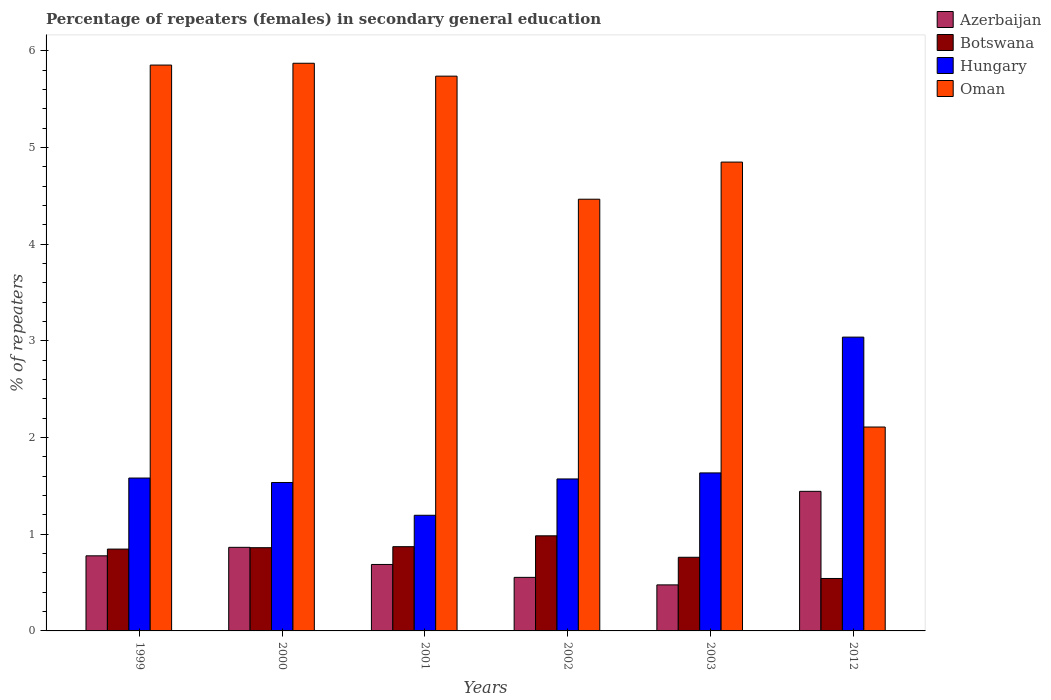How many different coloured bars are there?
Provide a succinct answer. 4. How many groups of bars are there?
Give a very brief answer. 6. Are the number of bars on each tick of the X-axis equal?
Provide a short and direct response. Yes. In how many cases, is the number of bars for a given year not equal to the number of legend labels?
Keep it short and to the point. 0. What is the percentage of female repeaters in Hungary in 1999?
Offer a very short reply. 1.58. Across all years, what is the maximum percentage of female repeaters in Azerbaijan?
Give a very brief answer. 1.44. Across all years, what is the minimum percentage of female repeaters in Hungary?
Offer a very short reply. 1.2. In which year was the percentage of female repeaters in Botswana minimum?
Offer a very short reply. 2012. What is the total percentage of female repeaters in Azerbaijan in the graph?
Make the answer very short. 4.8. What is the difference between the percentage of female repeaters in Oman in 2002 and that in 2003?
Provide a short and direct response. -0.38. What is the difference between the percentage of female repeaters in Hungary in 2000 and the percentage of female repeaters in Botswana in 2012?
Your answer should be compact. 0.99. What is the average percentage of female repeaters in Azerbaijan per year?
Your answer should be compact. 0.8. In the year 2012, what is the difference between the percentage of female repeaters in Botswana and percentage of female repeaters in Hungary?
Your response must be concise. -2.5. What is the ratio of the percentage of female repeaters in Azerbaijan in 1999 to that in 2012?
Your answer should be very brief. 0.54. Is the percentage of female repeaters in Oman in 2000 less than that in 2001?
Give a very brief answer. No. Is the difference between the percentage of female repeaters in Botswana in 1999 and 2012 greater than the difference between the percentage of female repeaters in Hungary in 1999 and 2012?
Your answer should be very brief. Yes. What is the difference between the highest and the second highest percentage of female repeaters in Oman?
Make the answer very short. 0.02. What is the difference between the highest and the lowest percentage of female repeaters in Botswana?
Your response must be concise. 0.44. Is it the case that in every year, the sum of the percentage of female repeaters in Azerbaijan and percentage of female repeaters in Oman is greater than the sum of percentage of female repeaters in Hungary and percentage of female repeaters in Botswana?
Make the answer very short. No. What does the 1st bar from the left in 2003 represents?
Ensure brevity in your answer.  Azerbaijan. What does the 4th bar from the right in 2001 represents?
Your answer should be compact. Azerbaijan. Is it the case that in every year, the sum of the percentage of female repeaters in Oman and percentage of female repeaters in Azerbaijan is greater than the percentage of female repeaters in Hungary?
Ensure brevity in your answer.  Yes. Are all the bars in the graph horizontal?
Give a very brief answer. No. What is the difference between two consecutive major ticks on the Y-axis?
Give a very brief answer. 1. Does the graph contain any zero values?
Offer a terse response. No. What is the title of the graph?
Your response must be concise. Percentage of repeaters (females) in secondary general education. What is the label or title of the Y-axis?
Offer a very short reply. % of repeaters. What is the % of repeaters of Azerbaijan in 1999?
Provide a short and direct response. 0.78. What is the % of repeaters in Botswana in 1999?
Offer a terse response. 0.85. What is the % of repeaters of Hungary in 1999?
Keep it short and to the point. 1.58. What is the % of repeaters in Oman in 1999?
Make the answer very short. 5.85. What is the % of repeaters of Azerbaijan in 2000?
Ensure brevity in your answer.  0.86. What is the % of repeaters of Botswana in 2000?
Make the answer very short. 0.86. What is the % of repeaters in Hungary in 2000?
Make the answer very short. 1.53. What is the % of repeaters in Oman in 2000?
Your answer should be very brief. 5.87. What is the % of repeaters of Azerbaijan in 2001?
Your answer should be very brief. 0.69. What is the % of repeaters in Botswana in 2001?
Provide a succinct answer. 0.87. What is the % of repeaters in Hungary in 2001?
Provide a succinct answer. 1.2. What is the % of repeaters in Oman in 2001?
Your answer should be very brief. 5.74. What is the % of repeaters of Azerbaijan in 2002?
Offer a very short reply. 0.55. What is the % of repeaters in Botswana in 2002?
Keep it short and to the point. 0.98. What is the % of repeaters in Hungary in 2002?
Your answer should be compact. 1.57. What is the % of repeaters of Oman in 2002?
Provide a short and direct response. 4.46. What is the % of repeaters in Azerbaijan in 2003?
Provide a short and direct response. 0.48. What is the % of repeaters of Botswana in 2003?
Provide a short and direct response. 0.76. What is the % of repeaters in Hungary in 2003?
Your answer should be compact. 1.63. What is the % of repeaters of Oman in 2003?
Ensure brevity in your answer.  4.85. What is the % of repeaters of Azerbaijan in 2012?
Offer a terse response. 1.44. What is the % of repeaters in Botswana in 2012?
Make the answer very short. 0.54. What is the % of repeaters of Hungary in 2012?
Offer a very short reply. 3.04. What is the % of repeaters of Oman in 2012?
Provide a succinct answer. 2.11. Across all years, what is the maximum % of repeaters in Azerbaijan?
Your response must be concise. 1.44. Across all years, what is the maximum % of repeaters of Botswana?
Provide a succinct answer. 0.98. Across all years, what is the maximum % of repeaters of Hungary?
Give a very brief answer. 3.04. Across all years, what is the maximum % of repeaters of Oman?
Provide a succinct answer. 5.87. Across all years, what is the minimum % of repeaters in Azerbaijan?
Ensure brevity in your answer.  0.48. Across all years, what is the minimum % of repeaters in Botswana?
Your answer should be very brief. 0.54. Across all years, what is the minimum % of repeaters of Hungary?
Your answer should be compact. 1.2. Across all years, what is the minimum % of repeaters of Oman?
Your response must be concise. 2.11. What is the total % of repeaters of Azerbaijan in the graph?
Provide a succinct answer. 4.8. What is the total % of repeaters of Botswana in the graph?
Make the answer very short. 4.87. What is the total % of repeaters in Hungary in the graph?
Provide a succinct answer. 10.56. What is the total % of repeaters in Oman in the graph?
Offer a very short reply. 28.88. What is the difference between the % of repeaters in Azerbaijan in 1999 and that in 2000?
Provide a succinct answer. -0.09. What is the difference between the % of repeaters of Botswana in 1999 and that in 2000?
Your answer should be compact. -0.01. What is the difference between the % of repeaters of Hungary in 1999 and that in 2000?
Offer a very short reply. 0.05. What is the difference between the % of repeaters of Oman in 1999 and that in 2000?
Provide a short and direct response. -0.02. What is the difference between the % of repeaters in Azerbaijan in 1999 and that in 2001?
Your answer should be very brief. 0.09. What is the difference between the % of repeaters in Botswana in 1999 and that in 2001?
Offer a terse response. -0.02. What is the difference between the % of repeaters in Hungary in 1999 and that in 2001?
Ensure brevity in your answer.  0.39. What is the difference between the % of repeaters of Oman in 1999 and that in 2001?
Provide a succinct answer. 0.11. What is the difference between the % of repeaters in Azerbaijan in 1999 and that in 2002?
Make the answer very short. 0.22. What is the difference between the % of repeaters in Botswana in 1999 and that in 2002?
Ensure brevity in your answer.  -0.14. What is the difference between the % of repeaters of Hungary in 1999 and that in 2002?
Provide a succinct answer. 0.01. What is the difference between the % of repeaters in Oman in 1999 and that in 2002?
Keep it short and to the point. 1.39. What is the difference between the % of repeaters of Azerbaijan in 1999 and that in 2003?
Your answer should be compact. 0.3. What is the difference between the % of repeaters in Botswana in 1999 and that in 2003?
Your answer should be compact. 0.08. What is the difference between the % of repeaters in Hungary in 1999 and that in 2003?
Your answer should be very brief. -0.05. What is the difference between the % of repeaters in Oman in 1999 and that in 2003?
Your response must be concise. 1. What is the difference between the % of repeaters of Azerbaijan in 1999 and that in 2012?
Offer a very short reply. -0.67. What is the difference between the % of repeaters of Botswana in 1999 and that in 2012?
Your answer should be compact. 0.3. What is the difference between the % of repeaters in Hungary in 1999 and that in 2012?
Provide a short and direct response. -1.46. What is the difference between the % of repeaters in Oman in 1999 and that in 2012?
Your answer should be compact. 3.74. What is the difference between the % of repeaters in Azerbaijan in 2000 and that in 2001?
Give a very brief answer. 0.18. What is the difference between the % of repeaters of Botswana in 2000 and that in 2001?
Provide a short and direct response. -0.01. What is the difference between the % of repeaters of Hungary in 2000 and that in 2001?
Provide a succinct answer. 0.34. What is the difference between the % of repeaters in Oman in 2000 and that in 2001?
Your answer should be very brief. 0.13. What is the difference between the % of repeaters of Azerbaijan in 2000 and that in 2002?
Your answer should be compact. 0.31. What is the difference between the % of repeaters of Botswana in 2000 and that in 2002?
Ensure brevity in your answer.  -0.12. What is the difference between the % of repeaters of Hungary in 2000 and that in 2002?
Offer a very short reply. -0.04. What is the difference between the % of repeaters of Oman in 2000 and that in 2002?
Offer a terse response. 1.41. What is the difference between the % of repeaters in Azerbaijan in 2000 and that in 2003?
Your response must be concise. 0.39. What is the difference between the % of repeaters in Botswana in 2000 and that in 2003?
Keep it short and to the point. 0.1. What is the difference between the % of repeaters of Hungary in 2000 and that in 2003?
Your answer should be compact. -0.1. What is the difference between the % of repeaters in Oman in 2000 and that in 2003?
Provide a succinct answer. 1.02. What is the difference between the % of repeaters in Azerbaijan in 2000 and that in 2012?
Make the answer very short. -0.58. What is the difference between the % of repeaters of Botswana in 2000 and that in 2012?
Keep it short and to the point. 0.32. What is the difference between the % of repeaters of Hungary in 2000 and that in 2012?
Provide a short and direct response. -1.5. What is the difference between the % of repeaters of Oman in 2000 and that in 2012?
Your answer should be very brief. 3.76. What is the difference between the % of repeaters of Azerbaijan in 2001 and that in 2002?
Your answer should be compact. 0.13. What is the difference between the % of repeaters in Botswana in 2001 and that in 2002?
Offer a terse response. -0.11. What is the difference between the % of repeaters of Hungary in 2001 and that in 2002?
Offer a terse response. -0.38. What is the difference between the % of repeaters in Oman in 2001 and that in 2002?
Keep it short and to the point. 1.27. What is the difference between the % of repeaters in Azerbaijan in 2001 and that in 2003?
Offer a very short reply. 0.21. What is the difference between the % of repeaters in Botswana in 2001 and that in 2003?
Provide a short and direct response. 0.11. What is the difference between the % of repeaters in Hungary in 2001 and that in 2003?
Offer a terse response. -0.44. What is the difference between the % of repeaters of Oman in 2001 and that in 2003?
Your answer should be compact. 0.89. What is the difference between the % of repeaters in Azerbaijan in 2001 and that in 2012?
Make the answer very short. -0.76. What is the difference between the % of repeaters of Botswana in 2001 and that in 2012?
Offer a terse response. 0.33. What is the difference between the % of repeaters in Hungary in 2001 and that in 2012?
Keep it short and to the point. -1.84. What is the difference between the % of repeaters in Oman in 2001 and that in 2012?
Make the answer very short. 3.63. What is the difference between the % of repeaters in Azerbaijan in 2002 and that in 2003?
Offer a terse response. 0.08. What is the difference between the % of repeaters of Botswana in 2002 and that in 2003?
Your answer should be very brief. 0.22. What is the difference between the % of repeaters in Hungary in 2002 and that in 2003?
Your response must be concise. -0.06. What is the difference between the % of repeaters in Oman in 2002 and that in 2003?
Make the answer very short. -0.38. What is the difference between the % of repeaters in Azerbaijan in 2002 and that in 2012?
Make the answer very short. -0.89. What is the difference between the % of repeaters in Botswana in 2002 and that in 2012?
Your answer should be very brief. 0.44. What is the difference between the % of repeaters in Hungary in 2002 and that in 2012?
Provide a succinct answer. -1.47. What is the difference between the % of repeaters in Oman in 2002 and that in 2012?
Keep it short and to the point. 2.36. What is the difference between the % of repeaters in Azerbaijan in 2003 and that in 2012?
Ensure brevity in your answer.  -0.97. What is the difference between the % of repeaters of Botswana in 2003 and that in 2012?
Offer a very short reply. 0.22. What is the difference between the % of repeaters in Hungary in 2003 and that in 2012?
Your answer should be very brief. -1.4. What is the difference between the % of repeaters in Oman in 2003 and that in 2012?
Keep it short and to the point. 2.74. What is the difference between the % of repeaters of Azerbaijan in 1999 and the % of repeaters of Botswana in 2000?
Provide a succinct answer. -0.08. What is the difference between the % of repeaters in Azerbaijan in 1999 and the % of repeaters in Hungary in 2000?
Give a very brief answer. -0.76. What is the difference between the % of repeaters of Azerbaijan in 1999 and the % of repeaters of Oman in 2000?
Provide a short and direct response. -5.09. What is the difference between the % of repeaters of Botswana in 1999 and the % of repeaters of Hungary in 2000?
Offer a very short reply. -0.69. What is the difference between the % of repeaters in Botswana in 1999 and the % of repeaters in Oman in 2000?
Your response must be concise. -5.02. What is the difference between the % of repeaters in Hungary in 1999 and the % of repeaters in Oman in 2000?
Keep it short and to the point. -4.29. What is the difference between the % of repeaters in Azerbaijan in 1999 and the % of repeaters in Botswana in 2001?
Your response must be concise. -0.09. What is the difference between the % of repeaters in Azerbaijan in 1999 and the % of repeaters in Hungary in 2001?
Provide a short and direct response. -0.42. What is the difference between the % of repeaters in Azerbaijan in 1999 and the % of repeaters in Oman in 2001?
Provide a succinct answer. -4.96. What is the difference between the % of repeaters of Botswana in 1999 and the % of repeaters of Hungary in 2001?
Offer a very short reply. -0.35. What is the difference between the % of repeaters of Botswana in 1999 and the % of repeaters of Oman in 2001?
Offer a terse response. -4.89. What is the difference between the % of repeaters of Hungary in 1999 and the % of repeaters of Oman in 2001?
Ensure brevity in your answer.  -4.16. What is the difference between the % of repeaters in Azerbaijan in 1999 and the % of repeaters in Botswana in 2002?
Make the answer very short. -0.21. What is the difference between the % of repeaters in Azerbaijan in 1999 and the % of repeaters in Hungary in 2002?
Make the answer very short. -0.8. What is the difference between the % of repeaters in Azerbaijan in 1999 and the % of repeaters in Oman in 2002?
Keep it short and to the point. -3.69. What is the difference between the % of repeaters in Botswana in 1999 and the % of repeaters in Hungary in 2002?
Make the answer very short. -0.73. What is the difference between the % of repeaters in Botswana in 1999 and the % of repeaters in Oman in 2002?
Offer a very short reply. -3.62. What is the difference between the % of repeaters of Hungary in 1999 and the % of repeaters of Oman in 2002?
Offer a very short reply. -2.88. What is the difference between the % of repeaters of Azerbaijan in 1999 and the % of repeaters of Botswana in 2003?
Your response must be concise. 0.01. What is the difference between the % of repeaters in Azerbaijan in 1999 and the % of repeaters in Hungary in 2003?
Offer a terse response. -0.86. What is the difference between the % of repeaters in Azerbaijan in 1999 and the % of repeaters in Oman in 2003?
Keep it short and to the point. -4.07. What is the difference between the % of repeaters of Botswana in 1999 and the % of repeaters of Hungary in 2003?
Offer a terse response. -0.79. What is the difference between the % of repeaters of Botswana in 1999 and the % of repeaters of Oman in 2003?
Offer a terse response. -4. What is the difference between the % of repeaters of Hungary in 1999 and the % of repeaters of Oman in 2003?
Your response must be concise. -3.27. What is the difference between the % of repeaters of Azerbaijan in 1999 and the % of repeaters of Botswana in 2012?
Provide a short and direct response. 0.23. What is the difference between the % of repeaters in Azerbaijan in 1999 and the % of repeaters in Hungary in 2012?
Provide a short and direct response. -2.26. What is the difference between the % of repeaters of Azerbaijan in 1999 and the % of repeaters of Oman in 2012?
Offer a terse response. -1.33. What is the difference between the % of repeaters in Botswana in 1999 and the % of repeaters in Hungary in 2012?
Your answer should be very brief. -2.19. What is the difference between the % of repeaters of Botswana in 1999 and the % of repeaters of Oman in 2012?
Your response must be concise. -1.26. What is the difference between the % of repeaters in Hungary in 1999 and the % of repeaters in Oman in 2012?
Your answer should be very brief. -0.53. What is the difference between the % of repeaters of Azerbaijan in 2000 and the % of repeaters of Botswana in 2001?
Your response must be concise. -0.01. What is the difference between the % of repeaters in Azerbaijan in 2000 and the % of repeaters in Hungary in 2001?
Keep it short and to the point. -0.33. What is the difference between the % of repeaters in Azerbaijan in 2000 and the % of repeaters in Oman in 2001?
Ensure brevity in your answer.  -4.87. What is the difference between the % of repeaters in Botswana in 2000 and the % of repeaters in Hungary in 2001?
Your answer should be very brief. -0.34. What is the difference between the % of repeaters of Botswana in 2000 and the % of repeaters of Oman in 2001?
Ensure brevity in your answer.  -4.88. What is the difference between the % of repeaters of Hungary in 2000 and the % of repeaters of Oman in 2001?
Ensure brevity in your answer.  -4.2. What is the difference between the % of repeaters in Azerbaijan in 2000 and the % of repeaters in Botswana in 2002?
Ensure brevity in your answer.  -0.12. What is the difference between the % of repeaters in Azerbaijan in 2000 and the % of repeaters in Hungary in 2002?
Ensure brevity in your answer.  -0.71. What is the difference between the % of repeaters in Azerbaijan in 2000 and the % of repeaters in Oman in 2002?
Give a very brief answer. -3.6. What is the difference between the % of repeaters in Botswana in 2000 and the % of repeaters in Hungary in 2002?
Your answer should be very brief. -0.71. What is the difference between the % of repeaters in Botswana in 2000 and the % of repeaters in Oman in 2002?
Make the answer very short. -3.6. What is the difference between the % of repeaters in Hungary in 2000 and the % of repeaters in Oman in 2002?
Offer a terse response. -2.93. What is the difference between the % of repeaters in Azerbaijan in 2000 and the % of repeaters in Botswana in 2003?
Your answer should be very brief. 0.1. What is the difference between the % of repeaters of Azerbaijan in 2000 and the % of repeaters of Hungary in 2003?
Give a very brief answer. -0.77. What is the difference between the % of repeaters in Azerbaijan in 2000 and the % of repeaters in Oman in 2003?
Keep it short and to the point. -3.98. What is the difference between the % of repeaters in Botswana in 2000 and the % of repeaters in Hungary in 2003?
Offer a very short reply. -0.77. What is the difference between the % of repeaters in Botswana in 2000 and the % of repeaters in Oman in 2003?
Your answer should be compact. -3.99. What is the difference between the % of repeaters of Hungary in 2000 and the % of repeaters of Oman in 2003?
Offer a very short reply. -3.31. What is the difference between the % of repeaters in Azerbaijan in 2000 and the % of repeaters in Botswana in 2012?
Your answer should be compact. 0.32. What is the difference between the % of repeaters of Azerbaijan in 2000 and the % of repeaters of Hungary in 2012?
Make the answer very short. -2.17. What is the difference between the % of repeaters in Azerbaijan in 2000 and the % of repeaters in Oman in 2012?
Offer a very short reply. -1.24. What is the difference between the % of repeaters in Botswana in 2000 and the % of repeaters in Hungary in 2012?
Keep it short and to the point. -2.18. What is the difference between the % of repeaters of Botswana in 2000 and the % of repeaters of Oman in 2012?
Your response must be concise. -1.25. What is the difference between the % of repeaters of Hungary in 2000 and the % of repeaters of Oman in 2012?
Your answer should be compact. -0.57. What is the difference between the % of repeaters of Azerbaijan in 2001 and the % of repeaters of Botswana in 2002?
Provide a short and direct response. -0.3. What is the difference between the % of repeaters in Azerbaijan in 2001 and the % of repeaters in Hungary in 2002?
Offer a very short reply. -0.88. What is the difference between the % of repeaters of Azerbaijan in 2001 and the % of repeaters of Oman in 2002?
Provide a short and direct response. -3.78. What is the difference between the % of repeaters in Botswana in 2001 and the % of repeaters in Hungary in 2002?
Ensure brevity in your answer.  -0.7. What is the difference between the % of repeaters in Botswana in 2001 and the % of repeaters in Oman in 2002?
Offer a terse response. -3.59. What is the difference between the % of repeaters of Hungary in 2001 and the % of repeaters of Oman in 2002?
Ensure brevity in your answer.  -3.27. What is the difference between the % of repeaters of Azerbaijan in 2001 and the % of repeaters of Botswana in 2003?
Provide a short and direct response. -0.07. What is the difference between the % of repeaters of Azerbaijan in 2001 and the % of repeaters of Hungary in 2003?
Your answer should be very brief. -0.95. What is the difference between the % of repeaters in Azerbaijan in 2001 and the % of repeaters in Oman in 2003?
Offer a very short reply. -4.16. What is the difference between the % of repeaters of Botswana in 2001 and the % of repeaters of Hungary in 2003?
Give a very brief answer. -0.76. What is the difference between the % of repeaters in Botswana in 2001 and the % of repeaters in Oman in 2003?
Your answer should be compact. -3.98. What is the difference between the % of repeaters of Hungary in 2001 and the % of repeaters of Oman in 2003?
Your response must be concise. -3.65. What is the difference between the % of repeaters of Azerbaijan in 2001 and the % of repeaters of Botswana in 2012?
Provide a succinct answer. 0.14. What is the difference between the % of repeaters of Azerbaijan in 2001 and the % of repeaters of Hungary in 2012?
Offer a terse response. -2.35. What is the difference between the % of repeaters in Azerbaijan in 2001 and the % of repeaters in Oman in 2012?
Give a very brief answer. -1.42. What is the difference between the % of repeaters in Botswana in 2001 and the % of repeaters in Hungary in 2012?
Make the answer very short. -2.17. What is the difference between the % of repeaters of Botswana in 2001 and the % of repeaters of Oman in 2012?
Your answer should be very brief. -1.24. What is the difference between the % of repeaters of Hungary in 2001 and the % of repeaters of Oman in 2012?
Provide a succinct answer. -0.91. What is the difference between the % of repeaters in Azerbaijan in 2002 and the % of repeaters in Botswana in 2003?
Keep it short and to the point. -0.21. What is the difference between the % of repeaters of Azerbaijan in 2002 and the % of repeaters of Hungary in 2003?
Ensure brevity in your answer.  -1.08. What is the difference between the % of repeaters in Azerbaijan in 2002 and the % of repeaters in Oman in 2003?
Offer a very short reply. -4.29. What is the difference between the % of repeaters of Botswana in 2002 and the % of repeaters of Hungary in 2003?
Your answer should be compact. -0.65. What is the difference between the % of repeaters of Botswana in 2002 and the % of repeaters of Oman in 2003?
Provide a short and direct response. -3.86. What is the difference between the % of repeaters in Hungary in 2002 and the % of repeaters in Oman in 2003?
Your response must be concise. -3.28. What is the difference between the % of repeaters of Azerbaijan in 2002 and the % of repeaters of Botswana in 2012?
Your response must be concise. 0.01. What is the difference between the % of repeaters in Azerbaijan in 2002 and the % of repeaters in Hungary in 2012?
Provide a succinct answer. -2.48. What is the difference between the % of repeaters of Azerbaijan in 2002 and the % of repeaters of Oman in 2012?
Give a very brief answer. -1.55. What is the difference between the % of repeaters of Botswana in 2002 and the % of repeaters of Hungary in 2012?
Give a very brief answer. -2.05. What is the difference between the % of repeaters of Botswana in 2002 and the % of repeaters of Oman in 2012?
Provide a short and direct response. -1.12. What is the difference between the % of repeaters of Hungary in 2002 and the % of repeaters of Oman in 2012?
Provide a short and direct response. -0.54. What is the difference between the % of repeaters in Azerbaijan in 2003 and the % of repeaters in Botswana in 2012?
Offer a terse response. -0.07. What is the difference between the % of repeaters in Azerbaijan in 2003 and the % of repeaters in Hungary in 2012?
Provide a short and direct response. -2.56. What is the difference between the % of repeaters in Azerbaijan in 2003 and the % of repeaters in Oman in 2012?
Keep it short and to the point. -1.63. What is the difference between the % of repeaters in Botswana in 2003 and the % of repeaters in Hungary in 2012?
Offer a very short reply. -2.28. What is the difference between the % of repeaters in Botswana in 2003 and the % of repeaters in Oman in 2012?
Give a very brief answer. -1.35. What is the difference between the % of repeaters of Hungary in 2003 and the % of repeaters of Oman in 2012?
Offer a terse response. -0.47. What is the average % of repeaters of Azerbaijan per year?
Your answer should be very brief. 0.8. What is the average % of repeaters of Botswana per year?
Your answer should be very brief. 0.81. What is the average % of repeaters of Hungary per year?
Make the answer very short. 1.76. What is the average % of repeaters of Oman per year?
Offer a terse response. 4.81. In the year 1999, what is the difference between the % of repeaters of Azerbaijan and % of repeaters of Botswana?
Keep it short and to the point. -0.07. In the year 1999, what is the difference between the % of repeaters of Azerbaijan and % of repeaters of Hungary?
Provide a succinct answer. -0.8. In the year 1999, what is the difference between the % of repeaters of Azerbaijan and % of repeaters of Oman?
Keep it short and to the point. -5.07. In the year 1999, what is the difference between the % of repeaters of Botswana and % of repeaters of Hungary?
Offer a terse response. -0.73. In the year 1999, what is the difference between the % of repeaters in Botswana and % of repeaters in Oman?
Ensure brevity in your answer.  -5.01. In the year 1999, what is the difference between the % of repeaters in Hungary and % of repeaters in Oman?
Provide a short and direct response. -4.27. In the year 2000, what is the difference between the % of repeaters of Azerbaijan and % of repeaters of Botswana?
Give a very brief answer. 0. In the year 2000, what is the difference between the % of repeaters in Azerbaijan and % of repeaters in Hungary?
Offer a very short reply. -0.67. In the year 2000, what is the difference between the % of repeaters in Azerbaijan and % of repeaters in Oman?
Ensure brevity in your answer.  -5.01. In the year 2000, what is the difference between the % of repeaters of Botswana and % of repeaters of Hungary?
Give a very brief answer. -0.67. In the year 2000, what is the difference between the % of repeaters of Botswana and % of repeaters of Oman?
Your answer should be very brief. -5.01. In the year 2000, what is the difference between the % of repeaters in Hungary and % of repeaters in Oman?
Your response must be concise. -4.34. In the year 2001, what is the difference between the % of repeaters in Azerbaijan and % of repeaters in Botswana?
Provide a short and direct response. -0.18. In the year 2001, what is the difference between the % of repeaters of Azerbaijan and % of repeaters of Hungary?
Give a very brief answer. -0.51. In the year 2001, what is the difference between the % of repeaters of Azerbaijan and % of repeaters of Oman?
Keep it short and to the point. -5.05. In the year 2001, what is the difference between the % of repeaters of Botswana and % of repeaters of Hungary?
Your response must be concise. -0.32. In the year 2001, what is the difference between the % of repeaters in Botswana and % of repeaters in Oman?
Your answer should be compact. -4.87. In the year 2001, what is the difference between the % of repeaters of Hungary and % of repeaters of Oman?
Offer a very short reply. -4.54. In the year 2002, what is the difference between the % of repeaters of Azerbaijan and % of repeaters of Botswana?
Your answer should be very brief. -0.43. In the year 2002, what is the difference between the % of repeaters of Azerbaijan and % of repeaters of Hungary?
Give a very brief answer. -1.02. In the year 2002, what is the difference between the % of repeaters of Azerbaijan and % of repeaters of Oman?
Provide a succinct answer. -3.91. In the year 2002, what is the difference between the % of repeaters in Botswana and % of repeaters in Hungary?
Keep it short and to the point. -0.59. In the year 2002, what is the difference between the % of repeaters of Botswana and % of repeaters of Oman?
Offer a very short reply. -3.48. In the year 2002, what is the difference between the % of repeaters in Hungary and % of repeaters in Oman?
Your response must be concise. -2.89. In the year 2003, what is the difference between the % of repeaters of Azerbaijan and % of repeaters of Botswana?
Provide a succinct answer. -0.29. In the year 2003, what is the difference between the % of repeaters in Azerbaijan and % of repeaters in Hungary?
Offer a very short reply. -1.16. In the year 2003, what is the difference between the % of repeaters of Azerbaijan and % of repeaters of Oman?
Keep it short and to the point. -4.37. In the year 2003, what is the difference between the % of repeaters in Botswana and % of repeaters in Hungary?
Offer a very short reply. -0.87. In the year 2003, what is the difference between the % of repeaters of Botswana and % of repeaters of Oman?
Your response must be concise. -4.09. In the year 2003, what is the difference between the % of repeaters in Hungary and % of repeaters in Oman?
Your response must be concise. -3.21. In the year 2012, what is the difference between the % of repeaters of Azerbaijan and % of repeaters of Botswana?
Provide a succinct answer. 0.9. In the year 2012, what is the difference between the % of repeaters in Azerbaijan and % of repeaters in Hungary?
Make the answer very short. -1.59. In the year 2012, what is the difference between the % of repeaters of Azerbaijan and % of repeaters of Oman?
Offer a terse response. -0.66. In the year 2012, what is the difference between the % of repeaters in Botswana and % of repeaters in Hungary?
Keep it short and to the point. -2.5. In the year 2012, what is the difference between the % of repeaters in Botswana and % of repeaters in Oman?
Provide a short and direct response. -1.57. In the year 2012, what is the difference between the % of repeaters of Hungary and % of repeaters of Oman?
Your answer should be compact. 0.93. What is the ratio of the % of repeaters in Azerbaijan in 1999 to that in 2000?
Provide a succinct answer. 0.9. What is the ratio of the % of repeaters in Botswana in 1999 to that in 2000?
Provide a succinct answer. 0.98. What is the ratio of the % of repeaters in Hungary in 1999 to that in 2000?
Your response must be concise. 1.03. What is the ratio of the % of repeaters of Oman in 1999 to that in 2000?
Provide a succinct answer. 1. What is the ratio of the % of repeaters in Azerbaijan in 1999 to that in 2001?
Make the answer very short. 1.13. What is the ratio of the % of repeaters of Botswana in 1999 to that in 2001?
Ensure brevity in your answer.  0.97. What is the ratio of the % of repeaters in Hungary in 1999 to that in 2001?
Provide a short and direct response. 1.32. What is the ratio of the % of repeaters of Azerbaijan in 1999 to that in 2002?
Ensure brevity in your answer.  1.4. What is the ratio of the % of repeaters of Botswana in 1999 to that in 2002?
Ensure brevity in your answer.  0.86. What is the ratio of the % of repeaters in Oman in 1999 to that in 2002?
Offer a terse response. 1.31. What is the ratio of the % of repeaters in Azerbaijan in 1999 to that in 2003?
Your answer should be very brief. 1.63. What is the ratio of the % of repeaters in Botswana in 1999 to that in 2003?
Provide a short and direct response. 1.11. What is the ratio of the % of repeaters of Hungary in 1999 to that in 2003?
Provide a succinct answer. 0.97. What is the ratio of the % of repeaters of Oman in 1999 to that in 2003?
Offer a terse response. 1.21. What is the ratio of the % of repeaters in Azerbaijan in 1999 to that in 2012?
Your answer should be compact. 0.54. What is the ratio of the % of repeaters of Botswana in 1999 to that in 2012?
Your answer should be compact. 1.56. What is the ratio of the % of repeaters in Hungary in 1999 to that in 2012?
Offer a terse response. 0.52. What is the ratio of the % of repeaters in Oman in 1999 to that in 2012?
Ensure brevity in your answer.  2.78. What is the ratio of the % of repeaters of Azerbaijan in 2000 to that in 2001?
Provide a succinct answer. 1.26. What is the ratio of the % of repeaters in Botswana in 2000 to that in 2001?
Your answer should be very brief. 0.99. What is the ratio of the % of repeaters in Hungary in 2000 to that in 2001?
Your answer should be very brief. 1.28. What is the ratio of the % of repeaters of Oman in 2000 to that in 2001?
Offer a very short reply. 1.02. What is the ratio of the % of repeaters of Azerbaijan in 2000 to that in 2002?
Offer a very short reply. 1.56. What is the ratio of the % of repeaters in Botswana in 2000 to that in 2002?
Provide a short and direct response. 0.88. What is the ratio of the % of repeaters of Hungary in 2000 to that in 2002?
Offer a very short reply. 0.98. What is the ratio of the % of repeaters of Oman in 2000 to that in 2002?
Your answer should be very brief. 1.31. What is the ratio of the % of repeaters in Azerbaijan in 2000 to that in 2003?
Ensure brevity in your answer.  1.82. What is the ratio of the % of repeaters of Botswana in 2000 to that in 2003?
Offer a terse response. 1.13. What is the ratio of the % of repeaters of Hungary in 2000 to that in 2003?
Provide a short and direct response. 0.94. What is the ratio of the % of repeaters in Oman in 2000 to that in 2003?
Offer a very short reply. 1.21. What is the ratio of the % of repeaters in Azerbaijan in 2000 to that in 2012?
Make the answer very short. 0.6. What is the ratio of the % of repeaters in Botswana in 2000 to that in 2012?
Provide a short and direct response. 1.59. What is the ratio of the % of repeaters in Hungary in 2000 to that in 2012?
Keep it short and to the point. 0.51. What is the ratio of the % of repeaters of Oman in 2000 to that in 2012?
Provide a succinct answer. 2.78. What is the ratio of the % of repeaters of Azerbaijan in 2001 to that in 2002?
Your response must be concise. 1.24. What is the ratio of the % of repeaters of Botswana in 2001 to that in 2002?
Keep it short and to the point. 0.89. What is the ratio of the % of repeaters of Hungary in 2001 to that in 2002?
Your answer should be compact. 0.76. What is the ratio of the % of repeaters of Oman in 2001 to that in 2002?
Offer a very short reply. 1.29. What is the ratio of the % of repeaters of Azerbaijan in 2001 to that in 2003?
Make the answer very short. 1.44. What is the ratio of the % of repeaters of Botswana in 2001 to that in 2003?
Provide a short and direct response. 1.14. What is the ratio of the % of repeaters of Hungary in 2001 to that in 2003?
Ensure brevity in your answer.  0.73. What is the ratio of the % of repeaters of Oman in 2001 to that in 2003?
Ensure brevity in your answer.  1.18. What is the ratio of the % of repeaters in Azerbaijan in 2001 to that in 2012?
Ensure brevity in your answer.  0.48. What is the ratio of the % of repeaters of Botswana in 2001 to that in 2012?
Make the answer very short. 1.61. What is the ratio of the % of repeaters in Hungary in 2001 to that in 2012?
Your response must be concise. 0.39. What is the ratio of the % of repeaters in Oman in 2001 to that in 2012?
Offer a terse response. 2.72. What is the ratio of the % of repeaters of Azerbaijan in 2002 to that in 2003?
Make the answer very short. 1.16. What is the ratio of the % of repeaters of Botswana in 2002 to that in 2003?
Provide a short and direct response. 1.29. What is the ratio of the % of repeaters of Hungary in 2002 to that in 2003?
Provide a succinct answer. 0.96. What is the ratio of the % of repeaters in Oman in 2002 to that in 2003?
Give a very brief answer. 0.92. What is the ratio of the % of repeaters of Azerbaijan in 2002 to that in 2012?
Offer a terse response. 0.38. What is the ratio of the % of repeaters in Botswana in 2002 to that in 2012?
Offer a terse response. 1.81. What is the ratio of the % of repeaters of Hungary in 2002 to that in 2012?
Ensure brevity in your answer.  0.52. What is the ratio of the % of repeaters of Oman in 2002 to that in 2012?
Your response must be concise. 2.12. What is the ratio of the % of repeaters in Azerbaijan in 2003 to that in 2012?
Provide a short and direct response. 0.33. What is the ratio of the % of repeaters in Botswana in 2003 to that in 2012?
Your response must be concise. 1.4. What is the ratio of the % of repeaters of Hungary in 2003 to that in 2012?
Your answer should be very brief. 0.54. What is the ratio of the % of repeaters of Oman in 2003 to that in 2012?
Your response must be concise. 2.3. What is the difference between the highest and the second highest % of repeaters of Azerbaijan?
Your answer should be very brief. 0.58. What is the difference between the highest and the second highest % of repeaters of Botswana?
Your response must be concise. 0.11. What is the difference between the highest and the second highest % of repeaters of Hungary?
Provide a short and direct response. 1.4. What is the difference between the highest and the second highest % of repeaters in Oman?
Your response must be concise. 0.02. What is the difference between the highest and the lowest % of repeaters in Azerbaijan?
Your response must be concise. 0.97. What is the difference between the highest and the lowest % of repeaters of Botswana?
Keep it short and to the point. 0.44. What is the difference between the highest and the lowest % of repeaters of Hungary?
Ensure brevity in your answer.  1.84. What is the difference between the highest and the lowest % of repeaters in Oman?
Your answer should be compact. 3.76. 